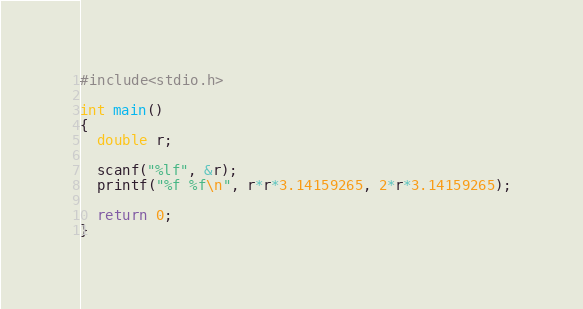Convert code to text. <code><loc_0><loc_0><loc_500><loc_500><_C_>#include<stdio.h>

int main()
{
  double r;

  scanf("%lf", &r);
  printf("%f %f\n", r*r*3.14159265, 2*r*3.14159265);

  return 0;
}</code> 